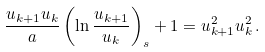Convert formula to latex. <formula><loc_0><loc_0><loc_500><loc_500>\frac { u _ { k + 1 } u _ { k } } { a } \left ( \ln \frac { u _ { k + 1 } } { u _ { k } } \right ) _ { s } + 1 = u ^ { 2 } _ { k + 1 } u ^ { 2 } _ { k } \, .</formula> 